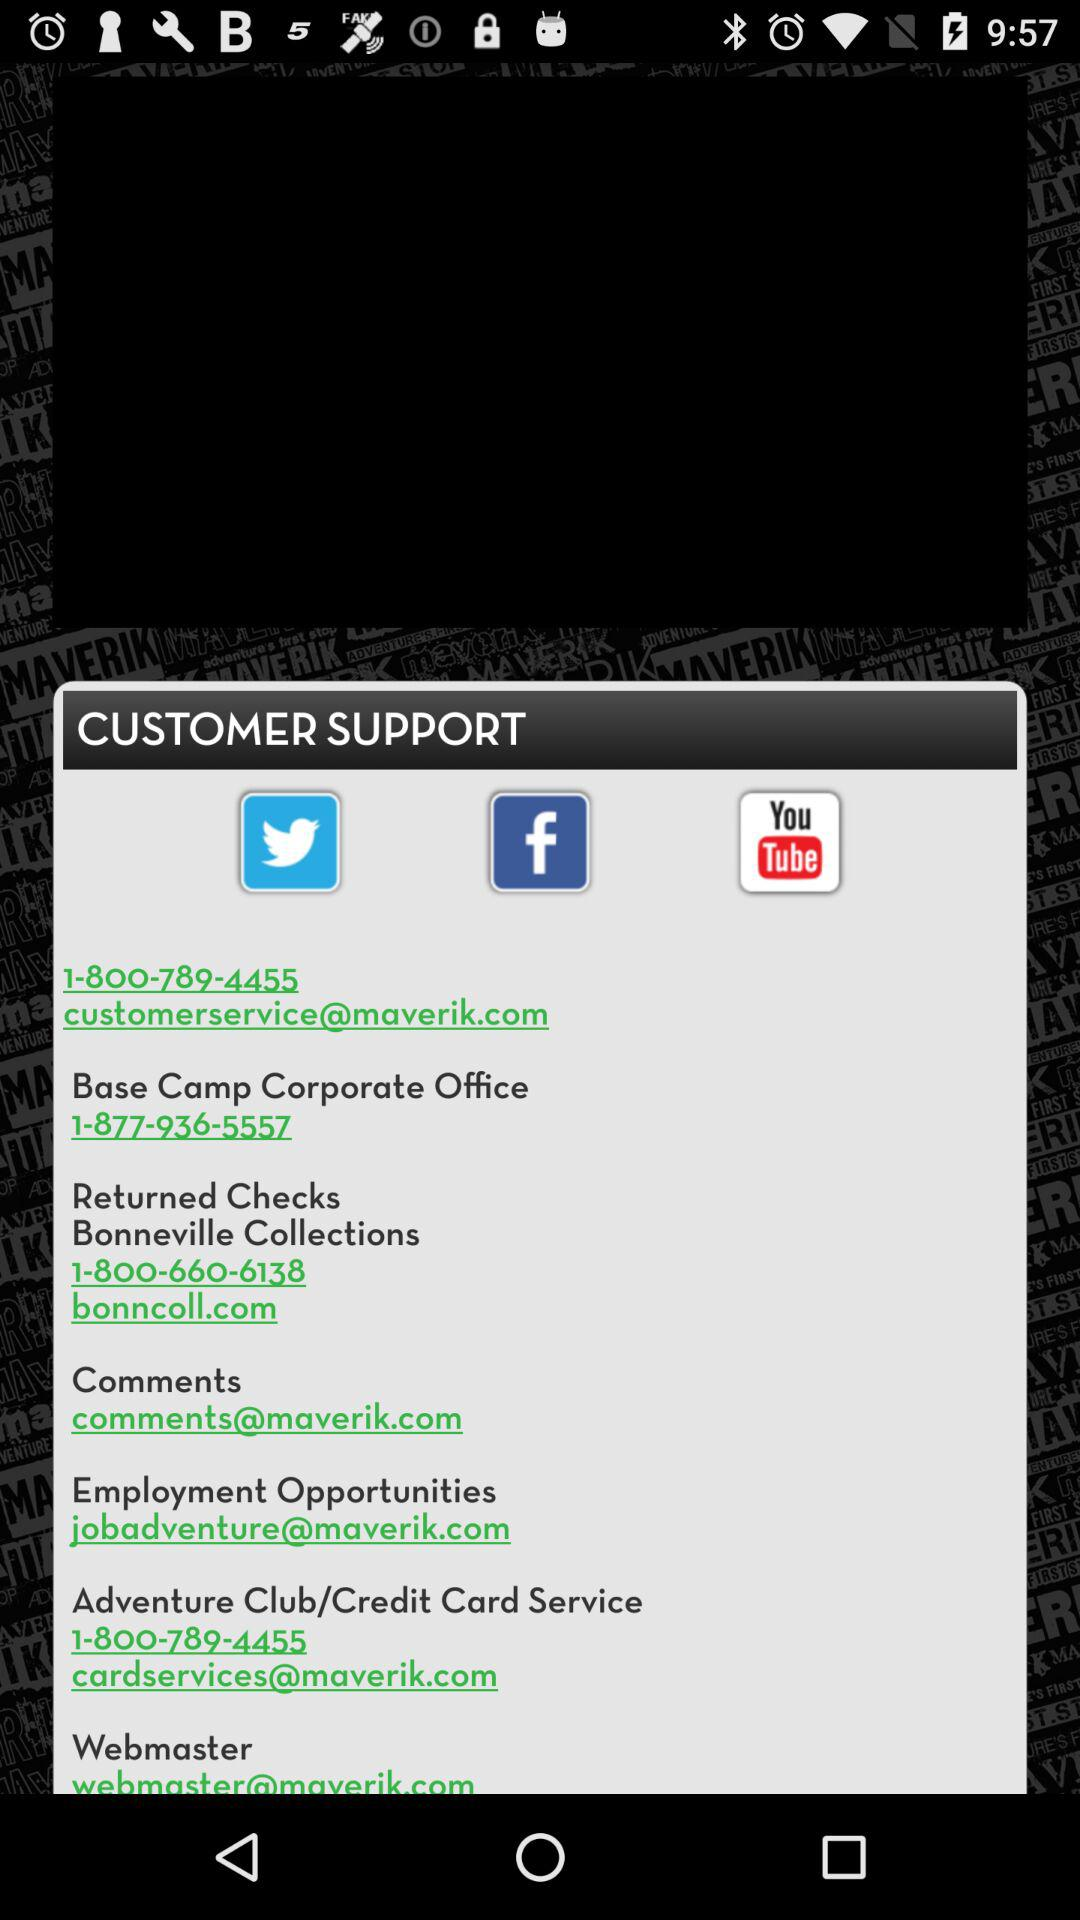What is the email address for "Employment Opportunities"? The email address for "Employment Opportunities" is jobadventure@maverik.com. 